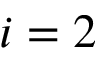<formula> <loc_0><loc_0><loc_500><loc_500>i = 2</formula> 